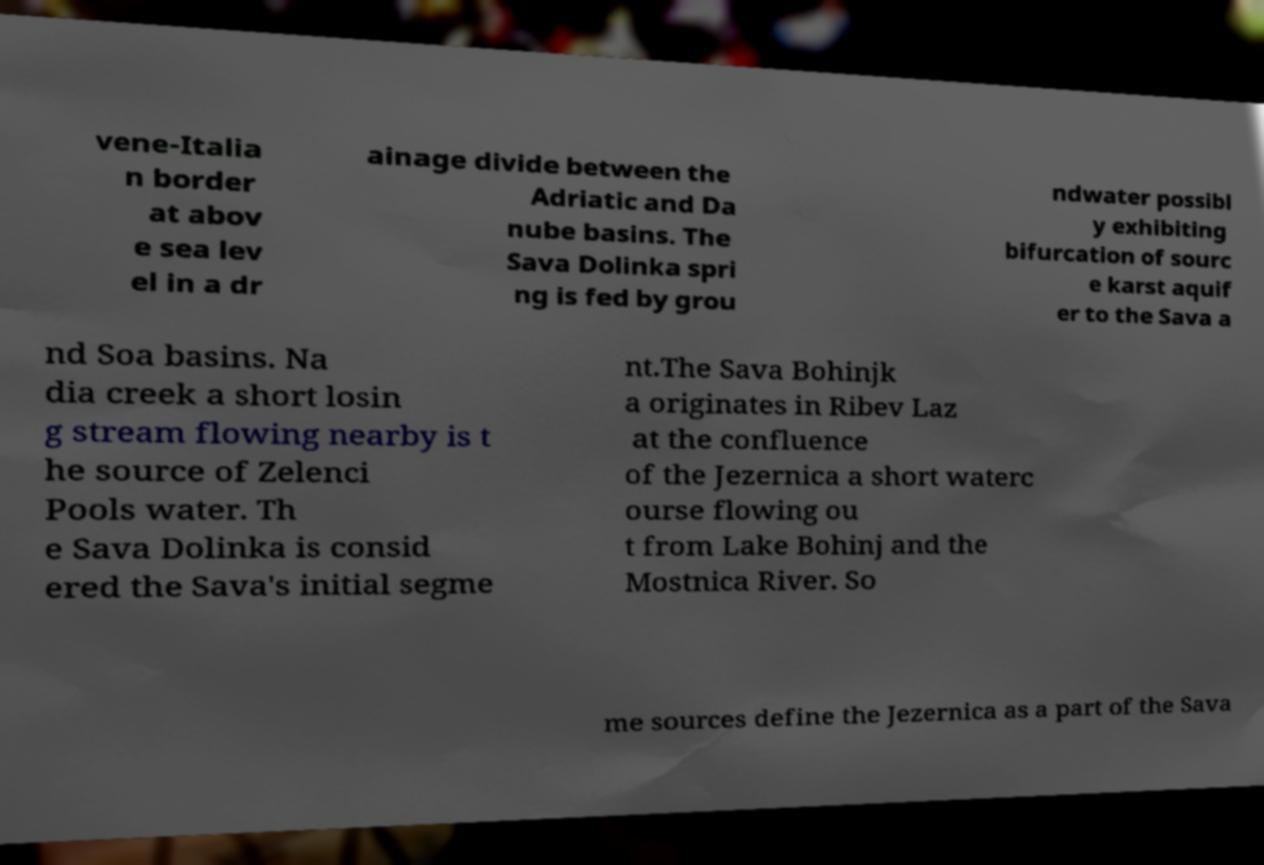Can you accurately transcribe the text from the provided image for me? vene-Italia n border at abov e sea lev el in a dr ainage divide between the Adriatic and Da nube basins. The Sava Dolinka spri ng is fed by grou ndwater possibl y exhibiting bifurcation of sourc e karst aquif er to the Sava a nd Soa basins. Na dia creek a short losin g stream flowing nearby is t he source of Zelenci Pools water. Th e Sava Dolinka is consid ered the Sava's initial segme nt.The Sava Bohinjk a originates in Ribev Laz at the confluence of the Jezernica a short waterc ourse flowing ou t from Lake Bohinj and the Mostnica River. So me sources define the Jezernica as a part of the Sava 